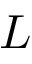<formula> <loc_0><loc_0><loc_500><loc_500>L</formula> 